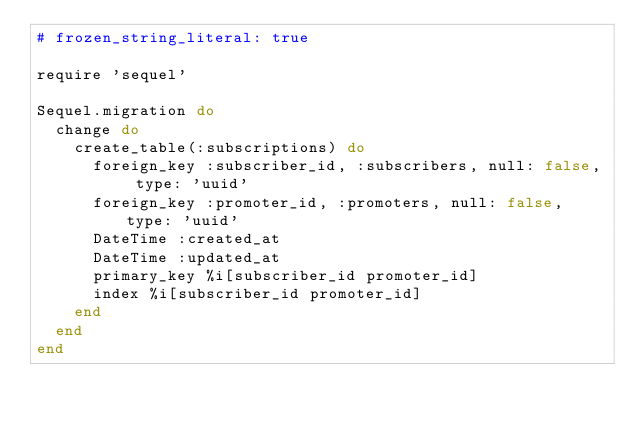<code> <loc_0><loc_0><loc_500><loc_500><_Ruby_># frozen_string_literal: true

require 'sequel'

Sequel.migration do
  change do
    create_table(:subscriptions) do
      foreign_key :subscriber_id, :subscribers, null: false, type: 'uuid'
      foreign_key :promoter_id, :promoters, null: false, type: 'uuid'
      DateTime :created_at
      DateTime :updated_at
      primary_key %i[subscriber_id promoter_id]
      index %i[subscriber_id promoter_id]
    end
  end
end
</code> 